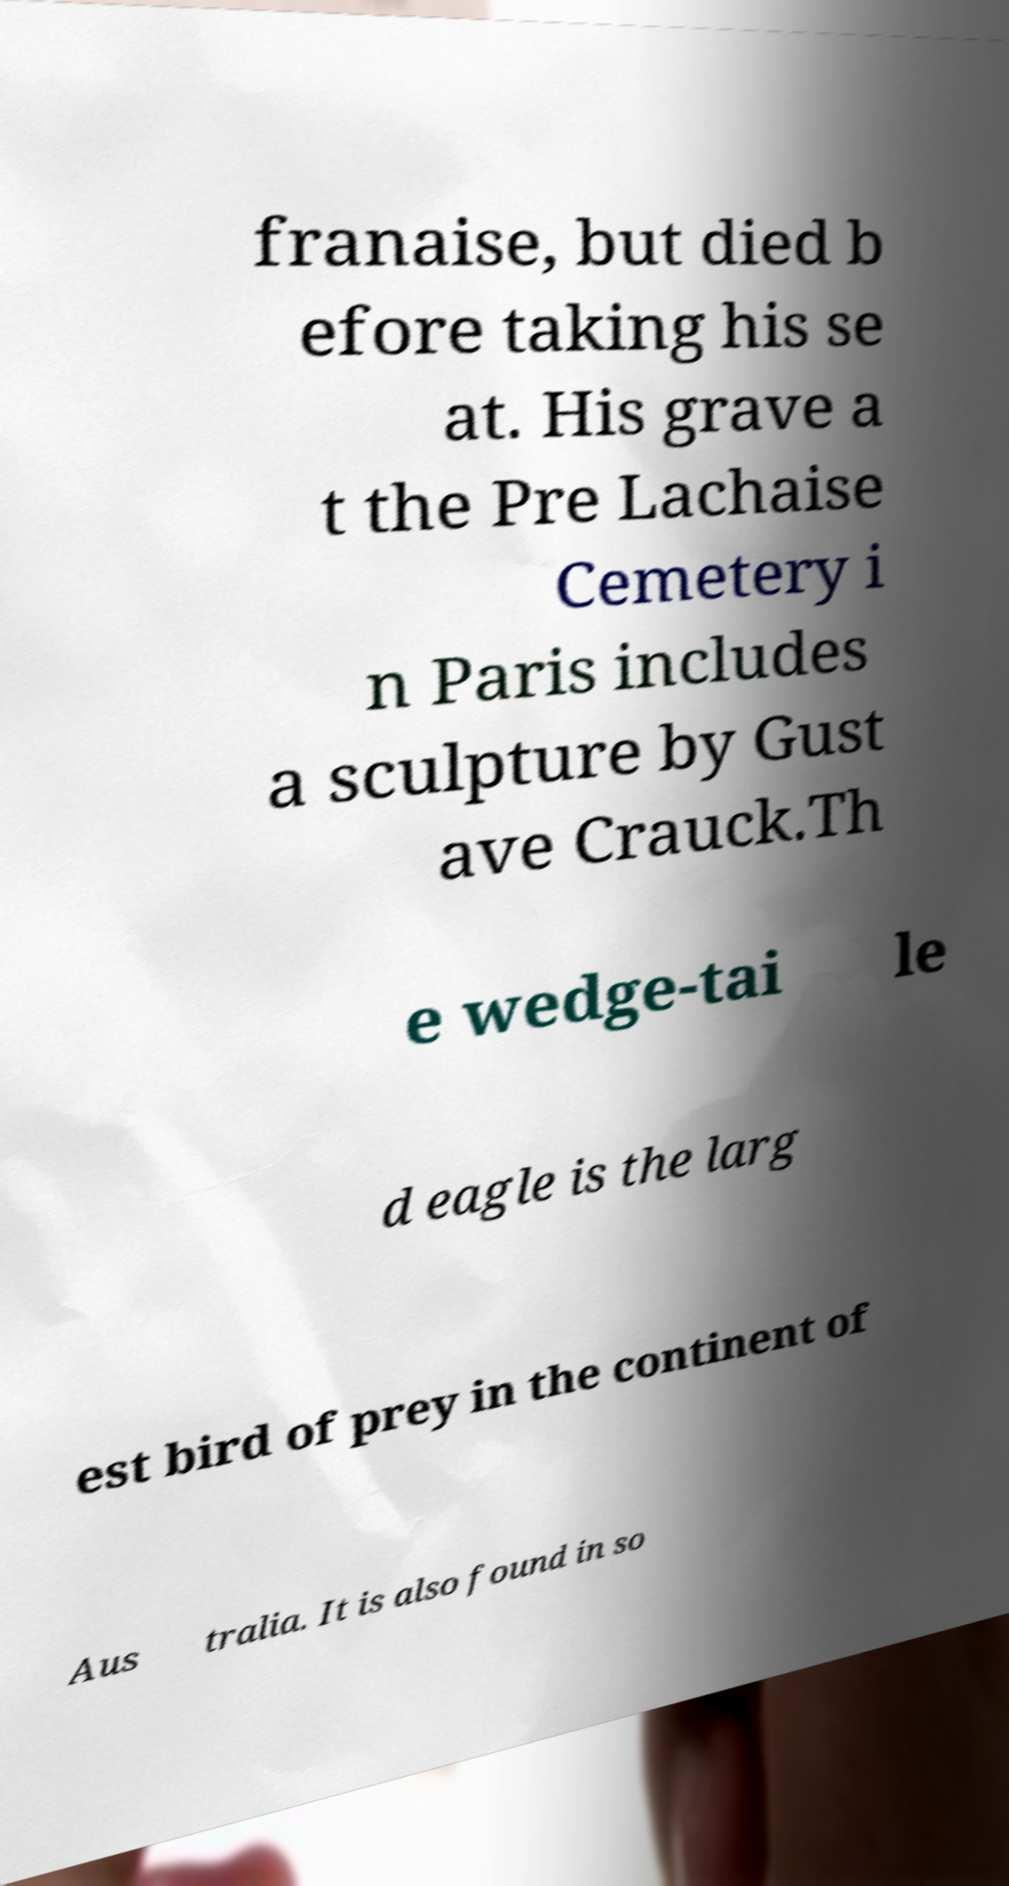There's text embedded in this image that I need extracted. Can you transcribe it verbatim? franaise, but died b efore taking his se at. His grave a t the Pre Lachaise Cemetery i n Paris includes a sculpture by Gust ave Crauck.Th e wedge-tai le d eagle is the larg est bird of prey in the continent of Aus tralia. It is also found in so 